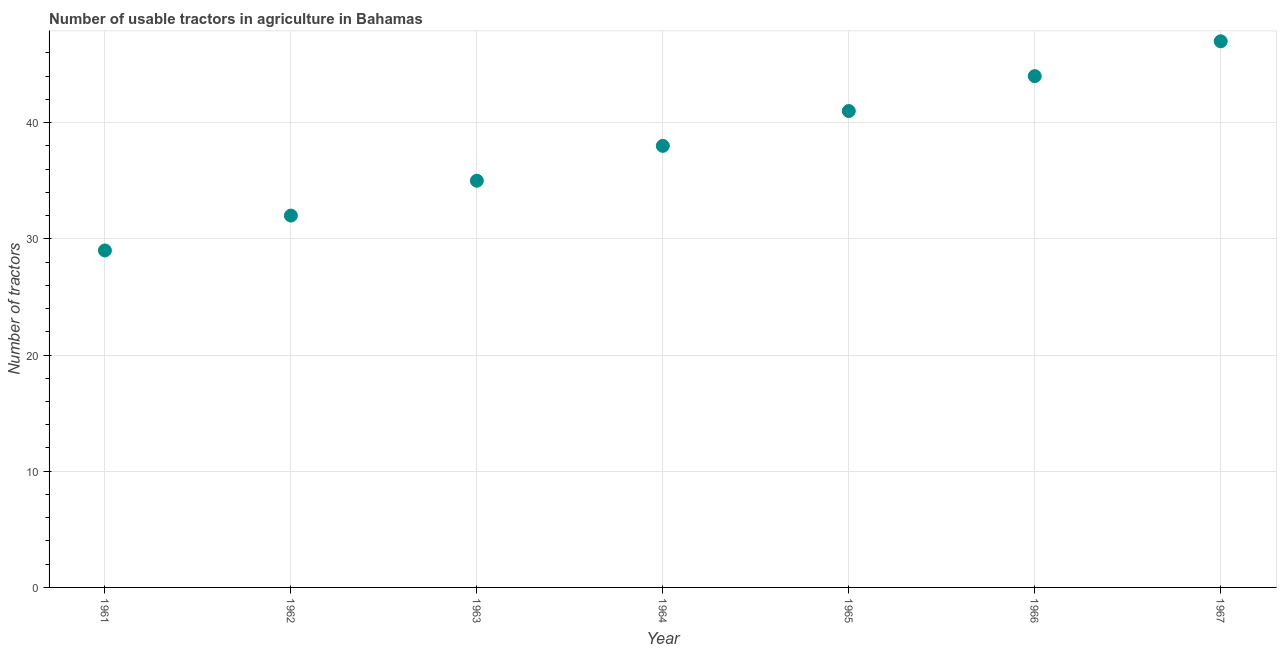What is the number of tractors in 1967?
Provide a succinct answer. 47. Across all years, what is the maximum number of tractors?
Provide a succinct answer. 47. Across all years, what is the minimum number of tractors?
Offer a terse response. 29. In which year was the number of tractors maximum?
Offer a very short reply. 1967. What is the sum of the number of tractors?
Your answer should be compact. 266. What is the difference between the number of tractors in 1962 and 1964?
Give a very brief answer. -6. What is the average number of tractors per year?
Offer a terse response. 38. In how many years, is the number of tractors greater than 32 ?
Make the answer very short. 5. What is the ratio of the number of tractors in 1963 to that in 1967?
Your response must be concise. 0.74. What is the difference between the highest and the lowest number of tractors?
Provide a short and direct response. 18. In how many years, is the number of tractors greater than the average number of tractors taken over all years?
Provide a short and direct response. 3. How many years are there in the graph?
Your response must be concise. 7. What is the difference between two consecutive major ticks on the Y-axis?
Provide a succinct answer. 10. Are the values on the major ticks of Y-axis written in scientific E-notation?
Offer a very short reply. No. Does the graph contain any zero values?
Provide a succinct answer. No. What is the title of the graph?
Give a very brief answer. Number of usable tractors in agriculture in Bahamas. What is the label or title of the Y-axis?
Make the answer very short. Number of tractors. What is the Number of tractors in 1961?
Offer a terse response. 29. What is the Number of tractors in 1962?
Your answer should be compact. 32. What is the Number of tractors in 1963?
Offer a terse response. 35. What is the Number of tractors in 1964?
Offer a very short reply. 38. What is the Number of tractors in 1965?
Your answer should be compact. 41. What is the Number of tractors in 1966?
Your response must be concise. 44. What is the difference between the Number of tractors in 1961 and 1962?
Provide a succinct answer. -3. What is the difference between the Number of tractors in 1961 and 1963?
Your response must be concise. -6. What is the difference between the Number of tractors in 1961 and 1964?
Your answer should be compact. -9. What is the difference between the Number of tractors in 1961 and 1966?
Ensure brevity in your answer.  -15. What is the difference between the Number of tractors in 1961 and 1967?
Provide a short and direct response. -18. What is the difference between the Number of tractors in 1963 and 1966?
Ensure brevity in your answer.  -9. What is the difference between the Number of tractors in 1963 and 1967?
Provide a succinct answer. -12. What is the difference between the Number of tractors in 1964 and 1965?
Offer a terse response. -3. What is the difference between the Number of tractors in 1964 and 1966?
Give a very brief answer. -6. What is the ratio of the Number of tractors in 1961 to that in 1962?
Offer a terse response. 0.91. What is the ratio of the Number of tractors in 1961 to that in 1963?
Your response must be concise. 0.83. What is the ratio of the Number of tractors in 1961 to that in 1964?
Provide a short and direct response. 0.76. What is the ratio of the Number of tractors in 1961 to that in 1965?
Provide a short and direct response. 0.71. What is the ratio of the Number of tractors in 1961 to that in 1966?
Give a very brief answer. 0.66. What is the ratio of the Number of tractors in 1961 to that in 1967?
Your answer should be very brief. 0.62. What is the ratio of the Number of tractors in 1962 to that in 1963?
Your response must be concise. 0.91. What is the ratio of the Number of tractors in 1962 to that in 1964?
Your answer should be very brief. 0.84. What is the ratio of the Number of tractors in 1962 to that in 1965?
Provide a short and direct response. 0.78. What is the ratio of the Number of tractors in 1962 to that in 1966?
Keep it short and to the point. 0.73. What is the ratio of the Number of tractors in 1962 to that in 1967?
Make the answer very short. 0.68. What is the ratio of the Number of tractors in 1963 to that in 1964?
Keep it short and to the point. 0.92. What is the ratio of the Number of tractors in 1963 to that in 1965?
Offer a terse response. 0.85. What is the ratio of the Number of tractors in 1963 to that in 1966?
Make the answer very short. 0.8. What is the ratio of the Number of tractors in 1963 to that in 1967?
Provide a short and direct response. 0.74. What is the ratio of the Number of tractors in 1964 to that in 1965?
Provide a succinct answer. 0.93. What is the ratio of the Number of tractors in 1964 to that in 1966?
Give a very brief answer. 0.86. What is the ratio of the Number of tractors in 1964 to that in 1967?
Provide a succinct answer. 0.81. What is the ratio of the Number of tractors in 1965 to that in 1966?
Your response must be concise. 0.93. What is the ratio of the Number of tractors in 1965 to that in 1967?
Your response must be concise. 0.87. What is the ratio of the Number of tractors in 1966 to that in 1967?
Offer a very short reply. 0.94. 